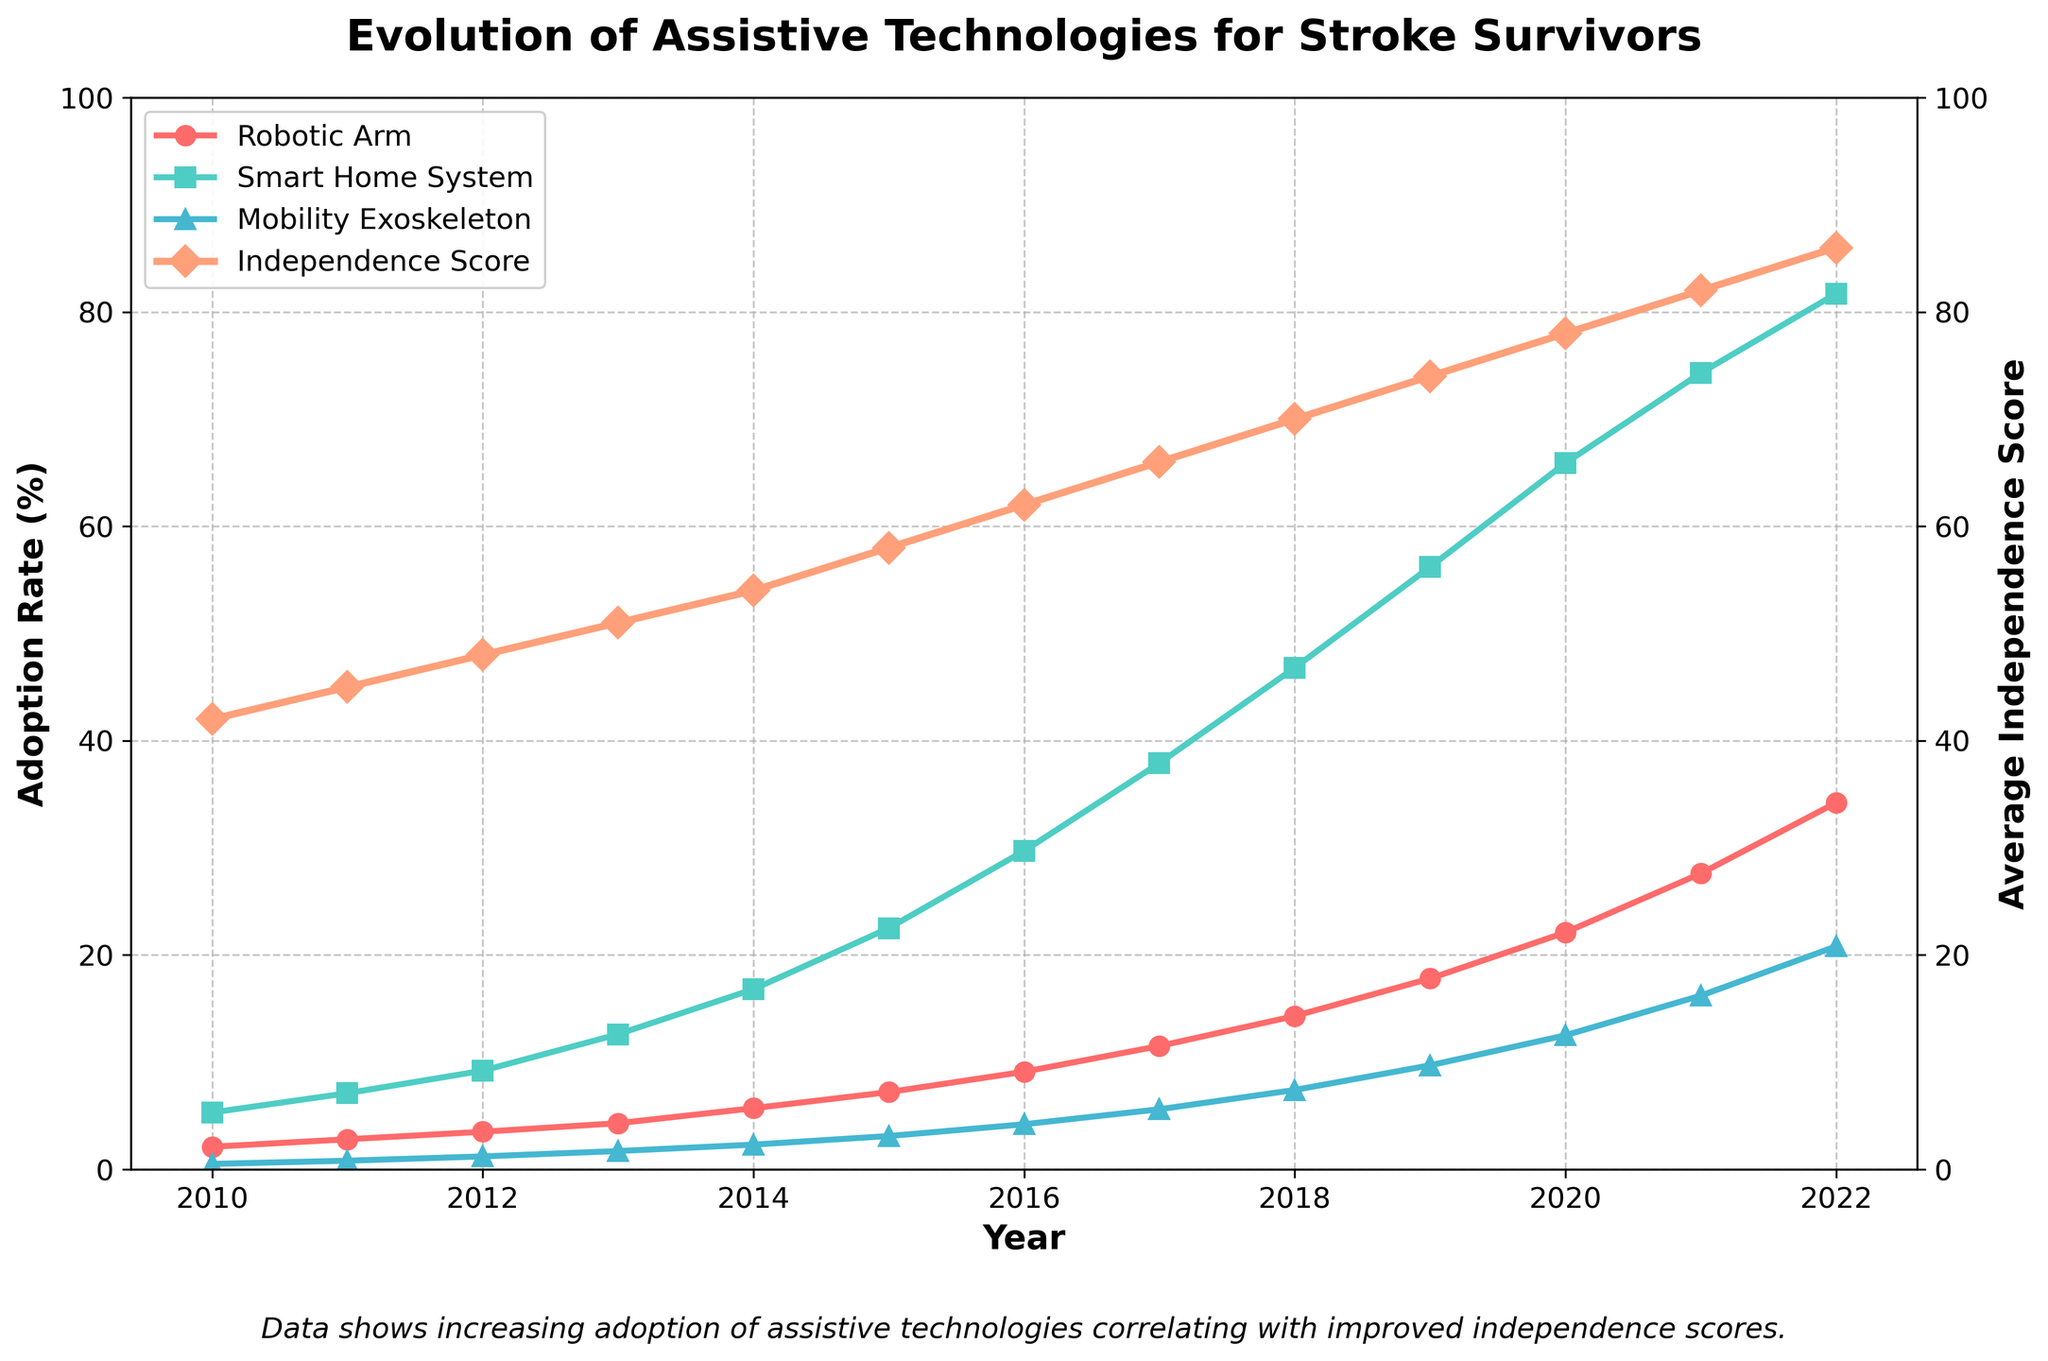Which assistive technology had the highest adoption rate by 2022? The lines representing the adoption rates for Robotic Arm, Smart Home System, and Mobility Exoskeleton are compared. The Smart Home System Adoption line is the highest by 2022.
Answer: Smart Home System What was the average independence score in 2015? The Average Independence Score line is checked at the year 2015. The score at this point is 58.
Answer: 58 What is the difference in Robotic Arm Adoption between 2012 and 2020? The adoption rate for Robotic Arm in 2012 is 3.5%, and in 2020 it is 22.1%. The difference is calculated by subtracting the 2012 value from the 2020 value: 22.1 - 3.5 = 18.6%.
Answer: 18.6% Which years had an Average Independence Score exactly at or above 75? The Independence Score line is examined to see where it meets or exceeds 75. These points are found in the years 2020, 2021, and 2022.
Answer: 2020, 2021, 2022 How did the Smart Home System Adoption rate change from 2010 to 2022? The Smart Home System Adoption line in 2010 is at 5.3%, and in 2022 it is at 81.7%. The change is calculated by subtracting the 2010 value from the 2022 value: 81.7 - 5.3 = 76.4%.
Answer: 76.4% Which technology showed the most significant increase in adoption rate from 2017 to 2021? Evaluating the changes in the lines representing Robotic Arm, Smart Home System, and Mobility Exoskeleton from 2017 to 2021, we find the Mob Exoskeleton line went from 5.6% to 16.2%, a 10.6% increase. The Robotic Arm went from 11.5% to 27.6%, a 16.1% increase. The Smart Home System went from 37.9% to 74.3%, a 36.4% increase.
Answer: Smart Home System How many times greater was the Smart Home System Adoption rate in 2022 compared to 2010? The Smart Home System Adoption rate in 2022 is 81.7% and in 2010 it is 5.3%. The ratio is calculated by dividing the 2022 value by the 2010 value: 81.7 / 5.3 ≈ 15.4.
Answer: 15.4 times Which year showed the highest gain in the average independence score compared to its previous year? Each year's Average Independence Score is compared against the previous year to find the largest difference. The increment between 2021 (82) and 2022 (86) is 4, which is the highest single-year increment.
Answer: 2022 